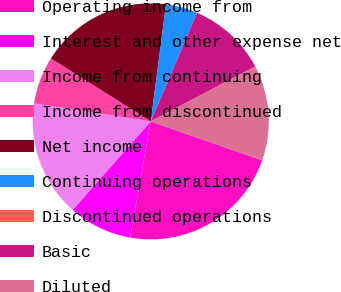<chart> <loc_0><loc_0><loc_500><loc_500><pie_chart><fcel>Operating income from<fcel>Interest and other expense net<fcel>Income from continuing<fcel>Income from discontinued<fcel>Net income<fcel>Continuing operations<fcel>Discontinued operations<fcel>Basic<fcel>Diluted<nl><fcel>22.46%<fcel>8.7%<fcel>15.93%<fcel>6.53%<fcel>18.11%<fcel>4.35%<fcel>0.0%<fcel>10.88%<fcel>13.05%<nl></chart> 